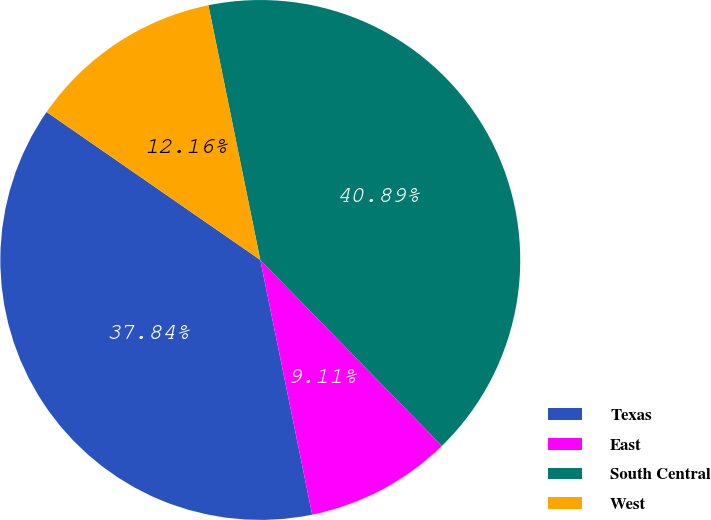Convert chart to OTSL. <chart><loc_0><loc_0><loc_500><loc_500><pie_chart><fcel>Texas<fcel>East<fcel>South Central<fcel>West<nl><fcel>37.84%<fcel>9.11%<fcel>40.89%<fcel>12.16%<nl></chart> 